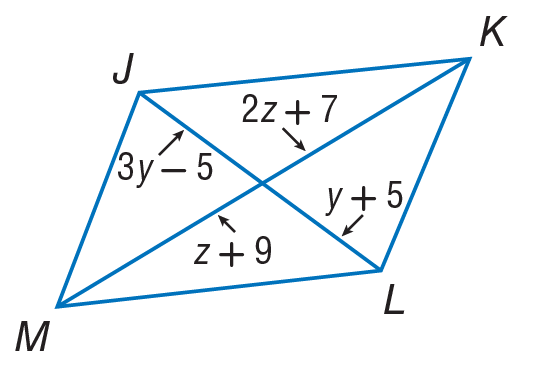Answer the mathemtical geometry problem and directly provide the correct option letter.
Question: Use parallelogram to find y.
Choices: A: 5 B: 10 C: 15 D: 20 A 